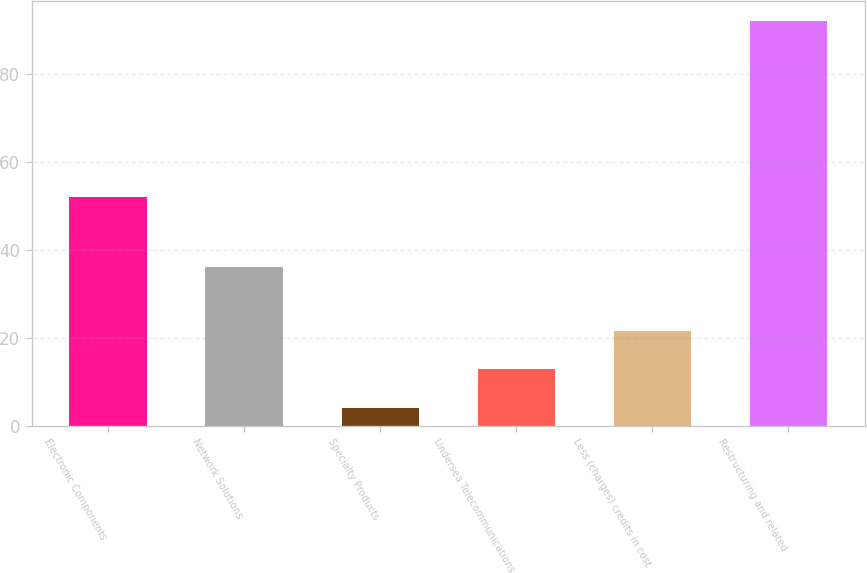Convert chart to OTSL. <chart><loc_0><loc_0><loc_500><loc_500><bar_chart><fcel>Electronic Components<fcel>Network Solutions<fcel>Specialty Products<fcel>Undersea Telecommunications<fcel>Less (charges) credits in cost<fcel>Restructuring and related<nl><fcel>52<fcel>36<fcel>4<fcel>12.8<fcel>21.6<fcel>92<nl></chart> 